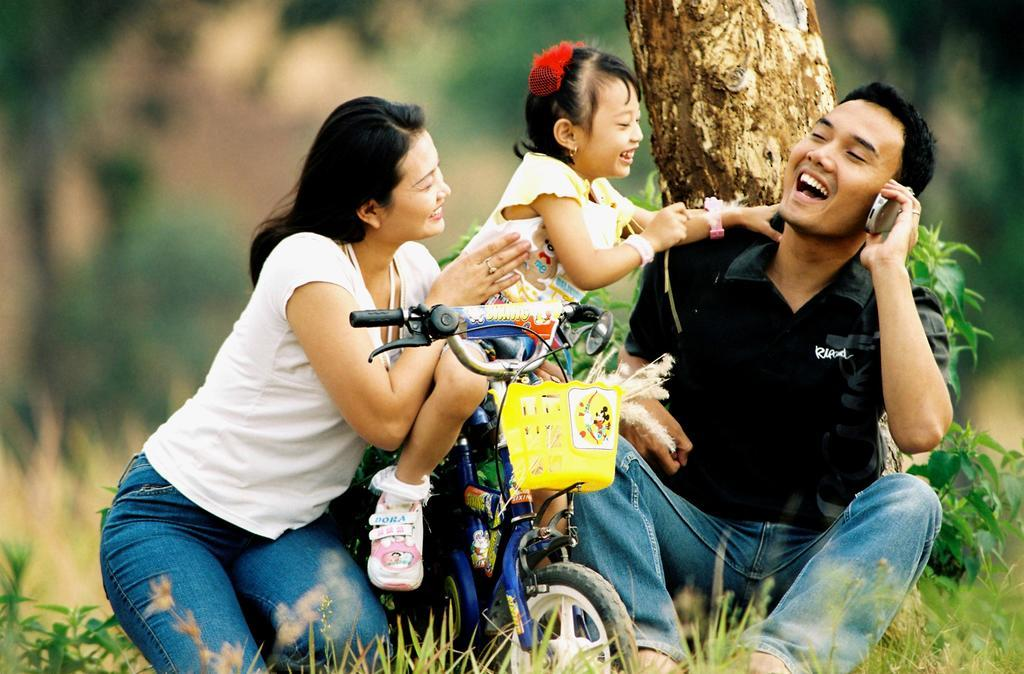How many people are present in the image? There are three people in the image: a man, a woman, and a baby girl. What is the baby girl doing in the image? The baby girl is sitting on a bicycle and playing with the man and woman. What type of vegetation can be seen in the image? There are plants and grass visible in the image. What type of jam is the baby girl eating in the image? There is no jam present in the image; the baby girl is playing with the man and woman. What type of meat can be seen in the image? There is no meat present in the image; the focus is on the people and the bicycle. 